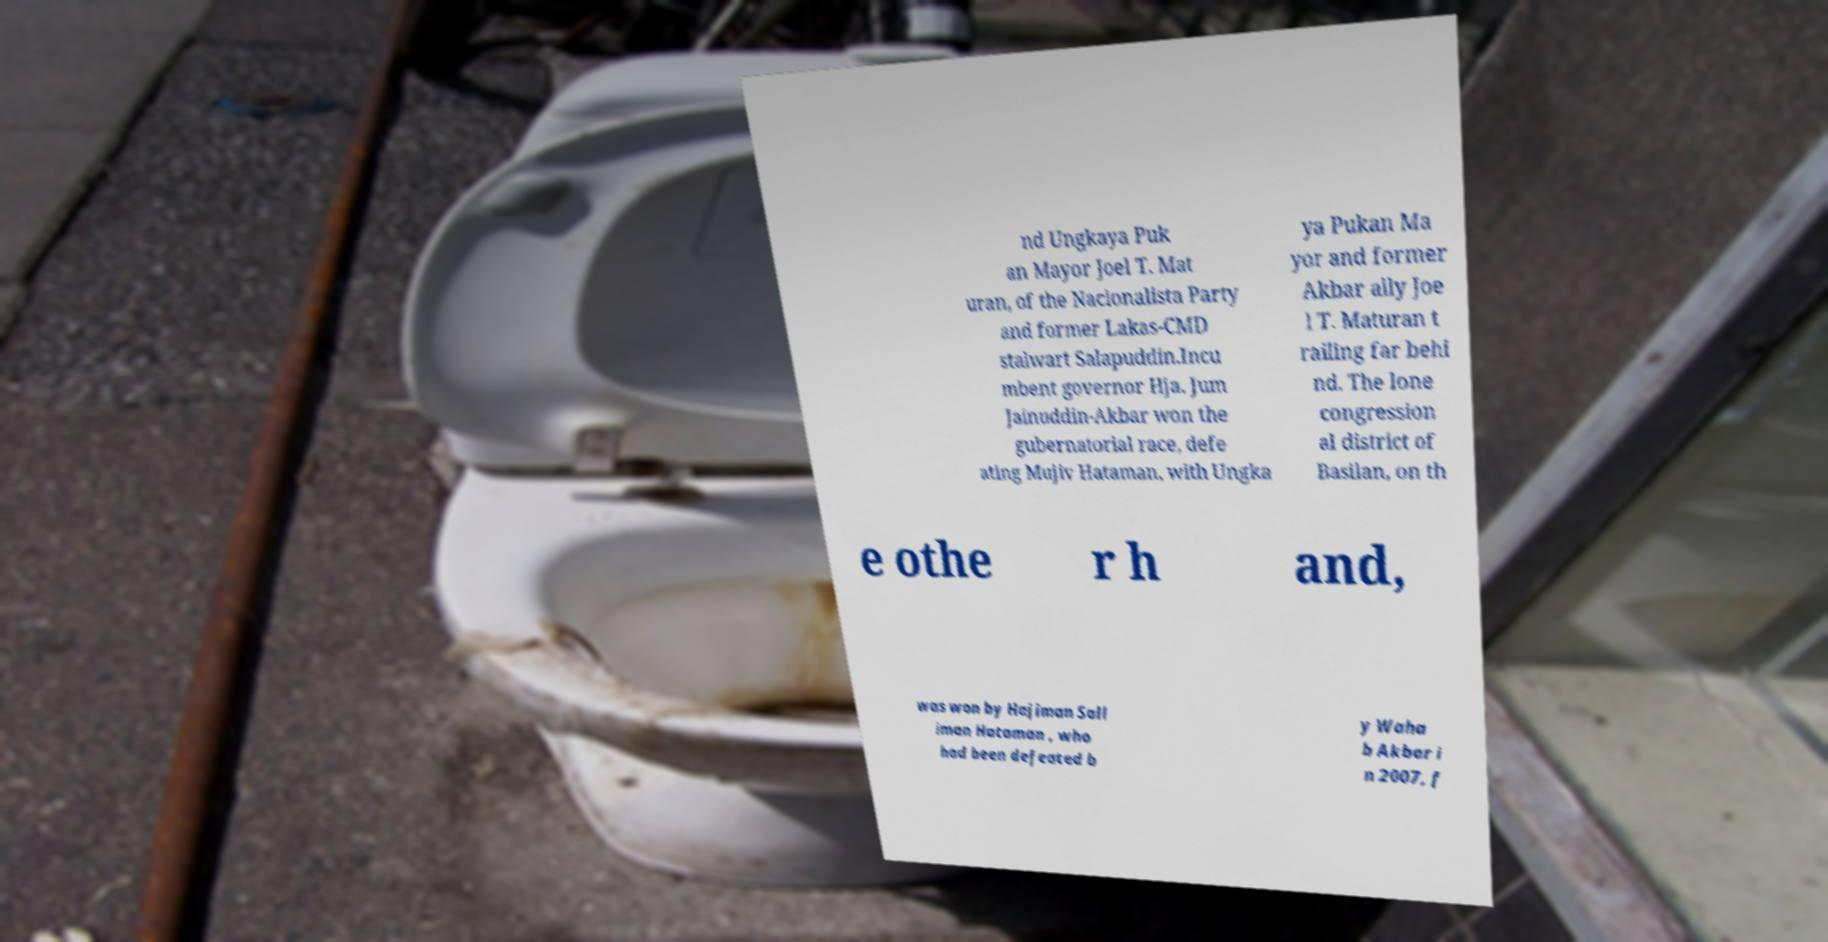Can you read and provide the text displayed in the image?This photo seems to have some interesting text. Can you extract and type it out for me? nd Ungkaya Puk an Mayor Joel T. Mat uran, of the Nacionalista Party and former Lakas-CMD stalwart Salapuddin.Incu mbent governor Hja. Jum Jainuddin-Akbar won the gubernatorial race, defe ating Mujiv Hataman, with Ungka ya Pukan Ma yor and former Akbar ally Joe l T. Maturan t railing far behi nd. The lone congression al district of Basilan, on th e othe r h and, was won by Hajiman Sall iman Hataman , who had been defeated b y Waha b Akbar i n 2007, f 